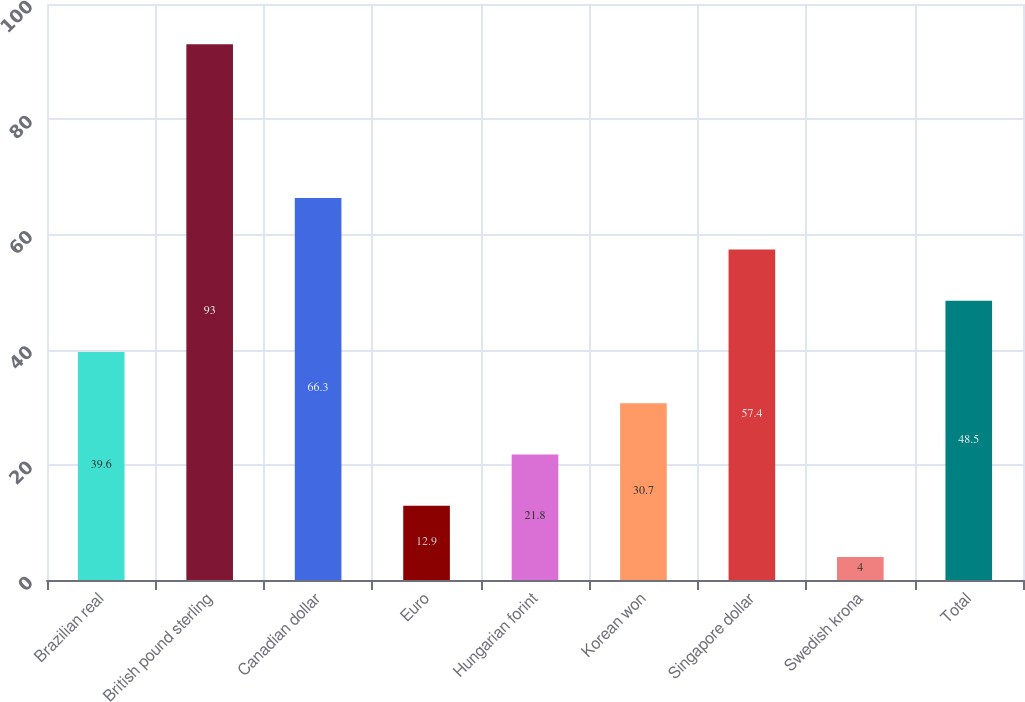Convert chart to OTSL. <chart><loc_0><loc_0><loc_500><loc_500><bar_chart><fcel>Brazilian real<fcel>British pound sterling<fcel>Canadian dollar<fcel>Euro<fcel>Hungarian forint<fcel>Korean won<fcel>Singapore dollar<fcel>Swedish krona<fcel>Total<nl><fcel>39.6<fcel>93<fcel>66.3<fcel>12.9<fcel>21.8<fcel>30.7<fcel>57.4<fcel>4<fcel>48.5<nl></chart> 